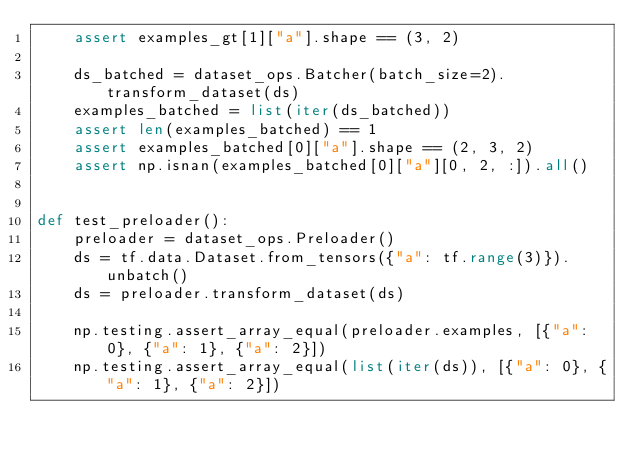Convert code to text. <code><loc_0><loc_0><loc_500><loc_500><_Python_>    assert examples_gt[1]["a"].shape == (3, 2)

    ds_batched = dataset_ops.Batcher(batch_size=2).transform_dataset(ds)
    examples_batched = list(iter(ds_batched))
    assert len(examples_batched) == 1
    assert examples_batched[0]["a"].shape == (2, 3, 2)
    assert np.isnan(examples_batched[0]["a"][0, 2, :]).all()


def test_preloader():
    preloader = dataset_ops.Preloader()
    ds = tf.data.Dataset.from_tensors({"a": tf.range(3)}).unbatch()
    ds = preloader.transform_dataset(ds)

    np.testing.assert_array_equal(preloader.examples, [{"a": 0}, {"a": 1}, {"a": 2}])
    np.testing.assert_array_equal(list(iter(ds)), [{"a": 0}, {"a": 1}, {"a": 2}])
</code> 